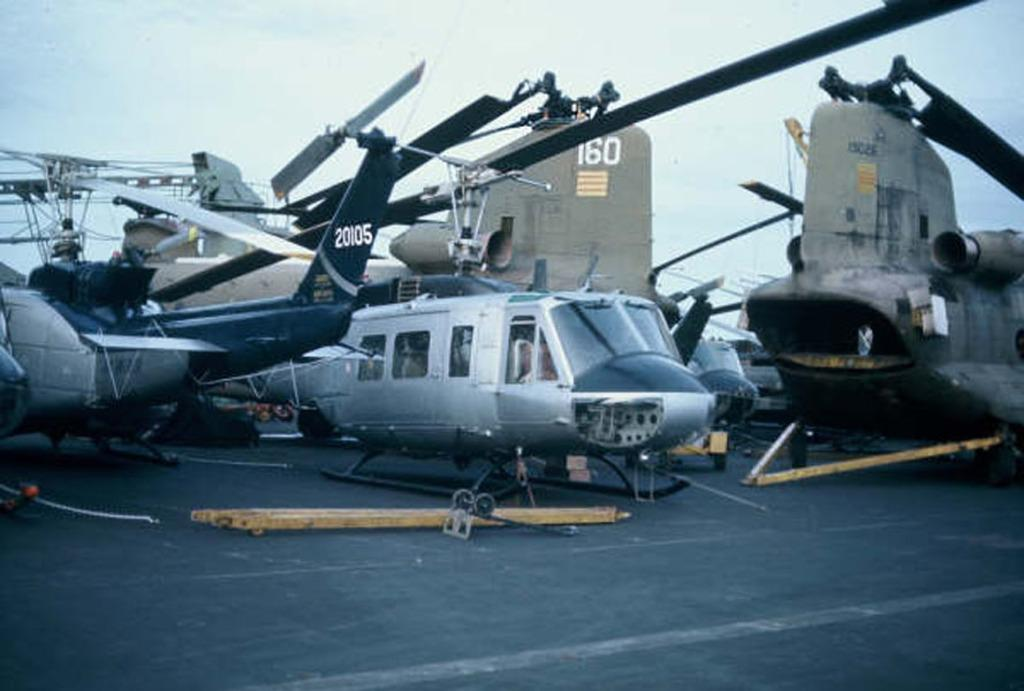<image>
Present a compact description of the photo's key features. Several planes and helicopters sit on a runway. One is numbered 20105 and another has the number 160 visible 